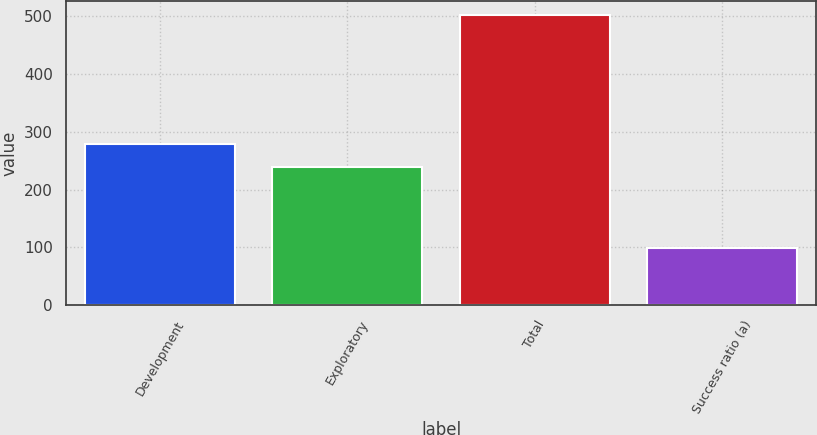<chart> <loc_0><loc_0><loc_500><loc_500><bar_chart><fcel>Development<fcel>Exploratory<fcel>Total<fcel>Success ratio (a)<nl><fcel>279.3<fcel>239<fcel>502<fcel>99<nl></chart> 